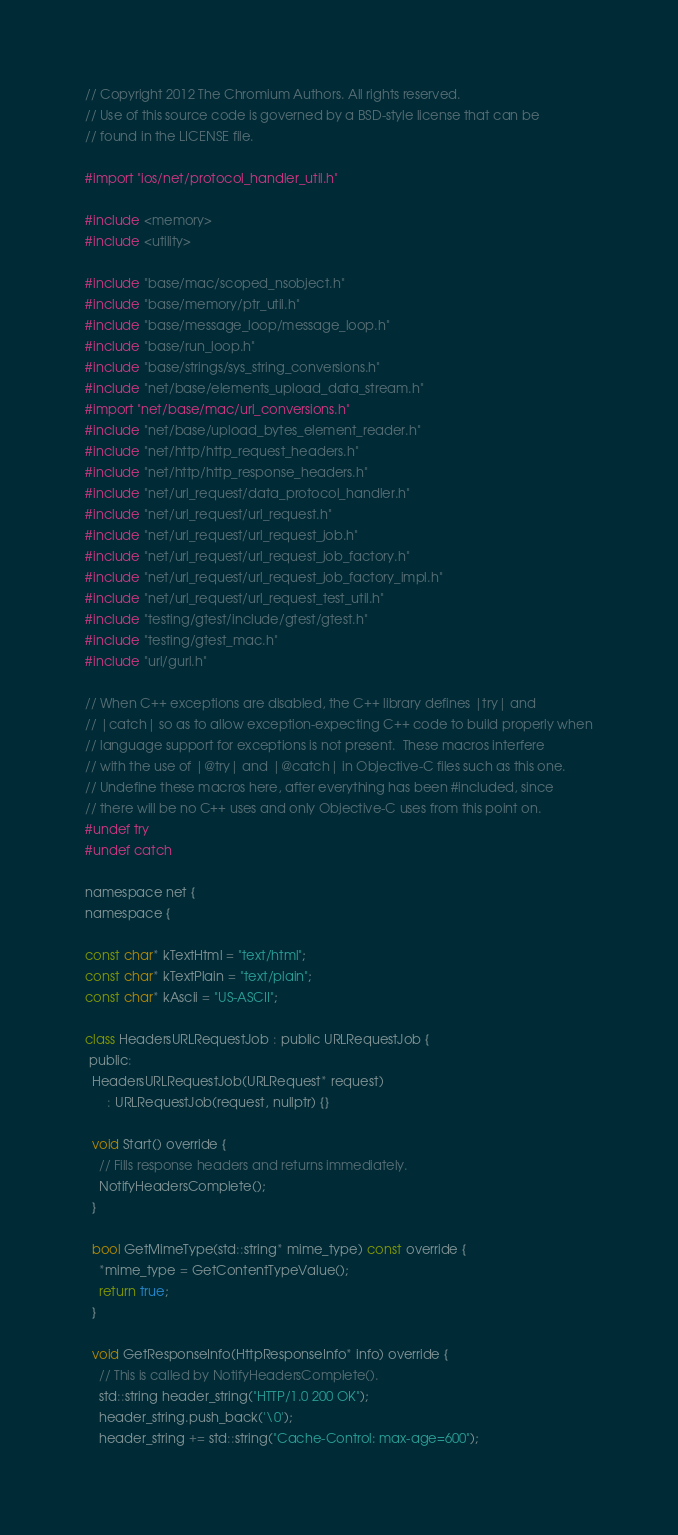<code> <loc_0><loc_0><loc_500><loc_500><_ObjectiveC_>// Copyright 2012 The Chromium Authors. All rights reserved.
// Use of this source code is governed by a BSD-style license that can be
// found in the LICENSE file.

#import "ios/net/protocol_handler_util.h"

#include <memory>
#include <utility>

#include "base/mac/scoped_nsobject.h"
#include "base/memory/ptr_util.h"
#include "base/message_loop/message_loop.h"
#include "base/run_loop.h"
#include "base/strings/sys_string_conversions.h"
#include "net/base/elements_upload_data_stream.h"
#import "net/base/mac/url_conversions.h"
#include "net/base/upload_bytes_element_reader.h"
#include "net/http/http_request_headers.h"
#include "net/http/http_response_headers.h"
#include "net/url_request/data_protocol_handler.h"
#include "net/url_request/url_request.h"
#include "net/url_request/url_request_job.h"
#include "net/url_request/url_request_job_factory.h"
#include "net/url_request/url_request_job_factory_impl.h"
#include "net/url_request/url_request_test_util.h"
#include "testing/gtest/include/gtest/gtest.h"
#include "testing/gtest_mac.h"
#include "url/gurl.h"

// When C++ exceptions are disabled, the C++ library defines |try| and
// |catch| so as to allow exception-expecting C++ code to build properly when
// language support for exceptions is not present.  These macros interfere
// with the use of |@try| and |@catch| in Objective-C files such as this one.
// Undefine these macros here, after everything has been #included, since
// there will be no C++ uses and only Objective-C uses from this point on.
#undef try
#undef catch

namespace net {
namespace {

const char* kTextHtml = "text/html";
const char* kTextPlain = "text/plain";
const char* kAscii = "US-ASCII";

class HeadersURLRequestJob : public URLRequestJob {
 public:
  HeadersURLRequestJob(URLRequest* request)
      : URLRequestJob(request, nullptr) {}

  void Start() override {
    // Fills response headers and returns immediately.
    NotifyHeadersComplete();
  }

  bool GetMimeType(std::string* mime_type) const override {
    *mime_type = GetContentTypeValue();
    return true;
  }

  void GetResponseInfo(HttpResponseInfo* info) override {
    // This is called by NotifyHeadersComplete().
    std::string header_string("HTTP/1.0 200 OK");
    header_string.push_back('\0');
    header_string += std::string("Cache-Control: max-age=600");</code> 